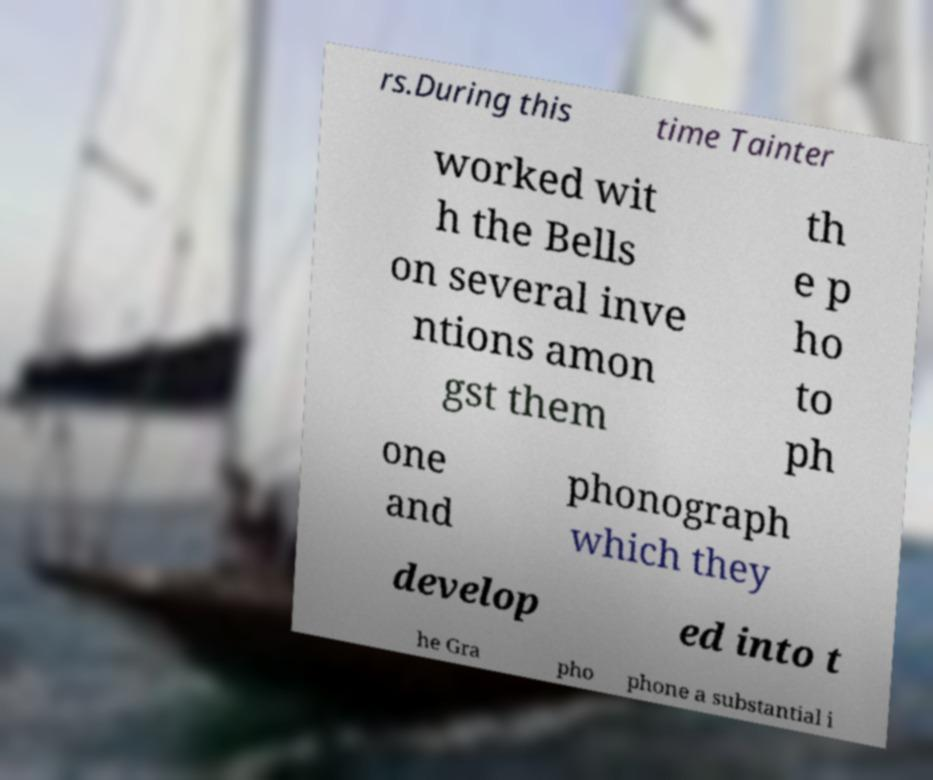Please read and relay the text visible in this image. What does it say? rs.During this time Tainter worked wit h the Bells on several inve ntions amon gst them th e p ho to ph one and phonograph which they develop ed into t he Gra pho phone a substantial i 